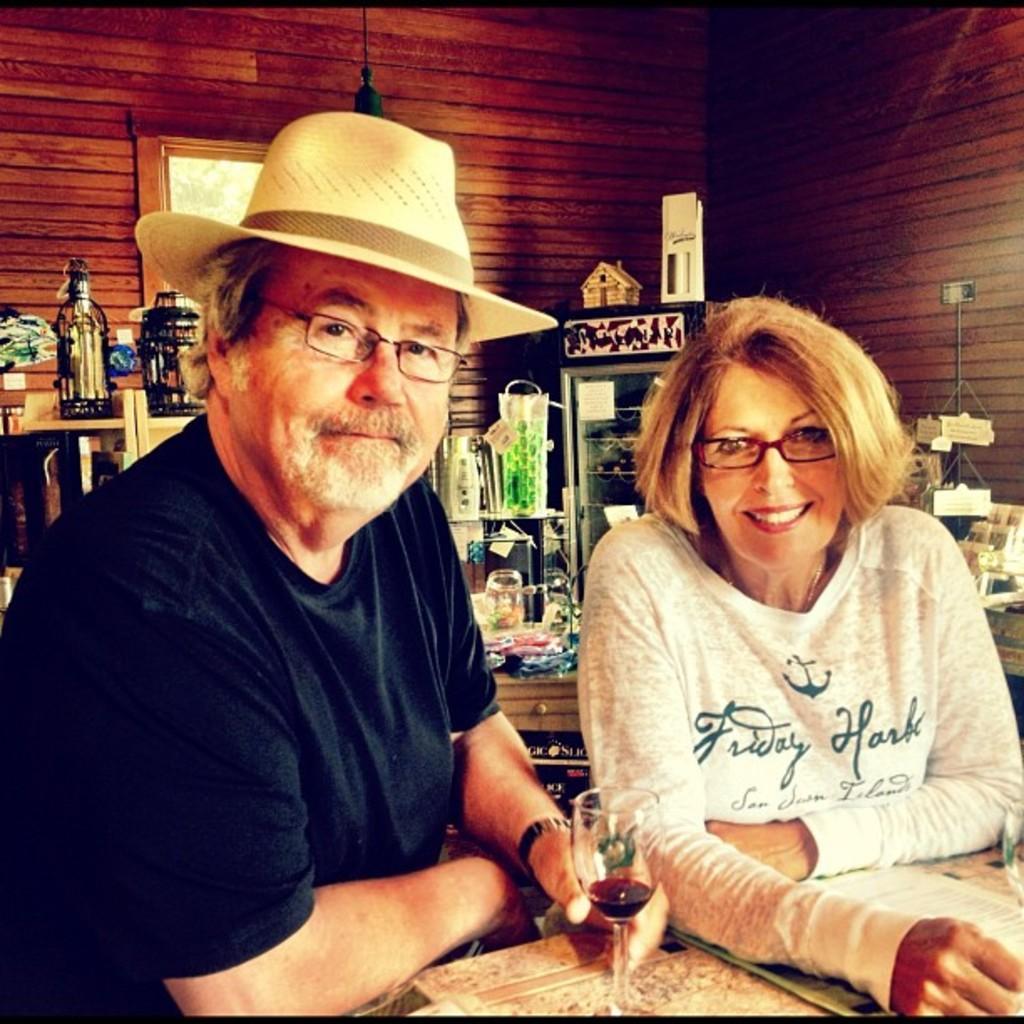Can you describe this image briefly? In this picture there is a man who is wearing hat, spectacle, t-shirt, watch and holding a wine glass. Beside him there is a woman who is standing near to the table. On the table I can see the papers. In the back I can see the fridge, beside that I can see the shelves. On the shelves I can see the bottles, boxes and kitchen appliance. In the top left there is a windows. 